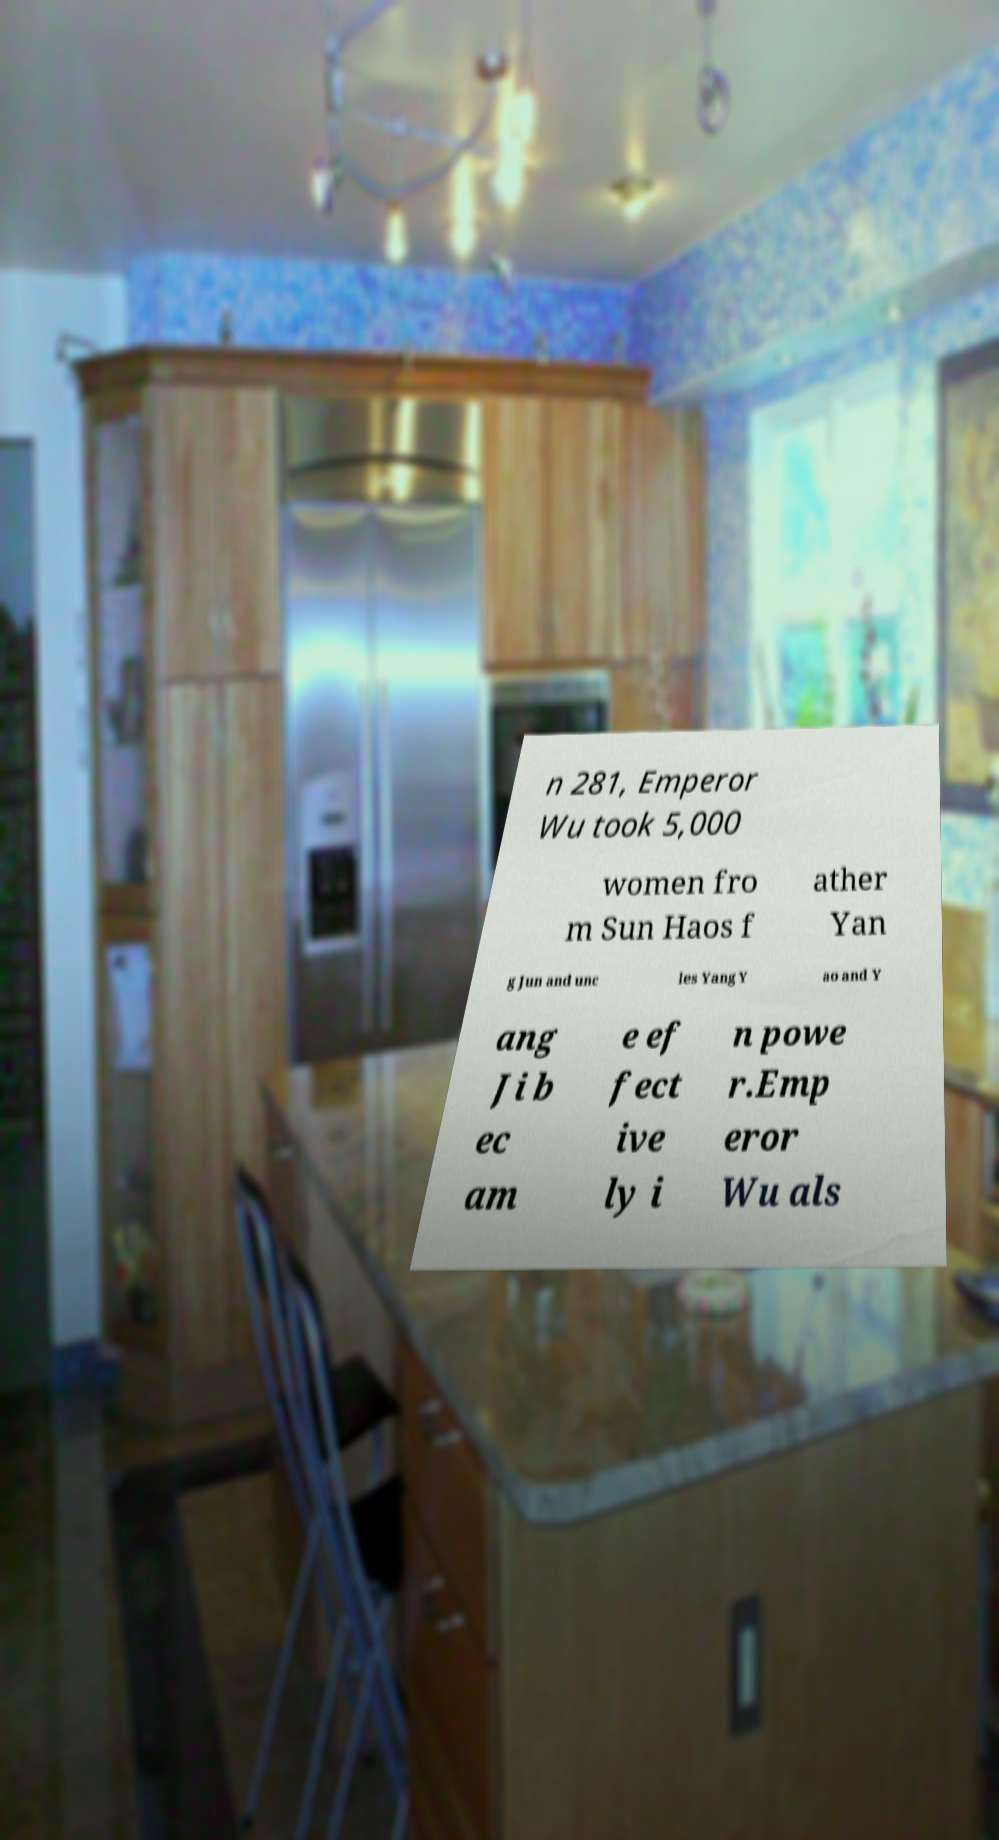Could you extract and type out the text from this image? n 281, Emperor Wu took 5,000 women fro m Sun Haos f ather Yan g Jun and unc les Yang Y ao and Y ang Ji b ec am e ef fect ive ly i n powe r.Emp eror Wu als 